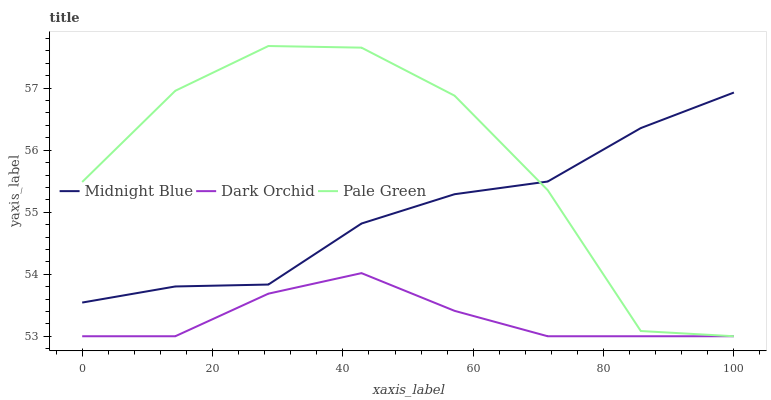Does Dark Orchid have the minimum area under the curve?
Answer yes or no. Yes. Does Pale Green have the maximum area under the curve?
Answer yes or no. Yes. Does Midnight Blue have the minimum area under the curve?
Answer yes or no. No. Does Midnight Blue have the maximum area under the curve?
Answer yes or no. No. Is Dark Orchid the smoothest?
Answer yes or no. Yes. Is Pale Green the roughest?
Answer yes or no. Yes. Is Midnight Blue the smoothest?
Answer yes or no. No. Is Midnight Blue the roughest?
Answer yes or no. No. Does Midnight Blue have the lowest value?
Answer yes or no. No. Does Pale Green have the highest value?
Answer yes or no. Yes. Does Midnight Blue have the highest value?
Answer yes or no. No. Is Dark Orchid less than Midnight Blue?
Answer yes or no. Yes. Is Midnight Blue greater than Dark Orchid?
Answer yes or no. Yes. Does Pale Green intersect Midnight Blue?
Answer yes or no. Yes. Is Pale Green less than Midnight Blue?
Answer yes or no. No. Is Pale Green greater than Midnight Blue?
Answer yes or no. No. Does Dark Orchid intersect Midnight Blue?
Answer yes or no. No. 